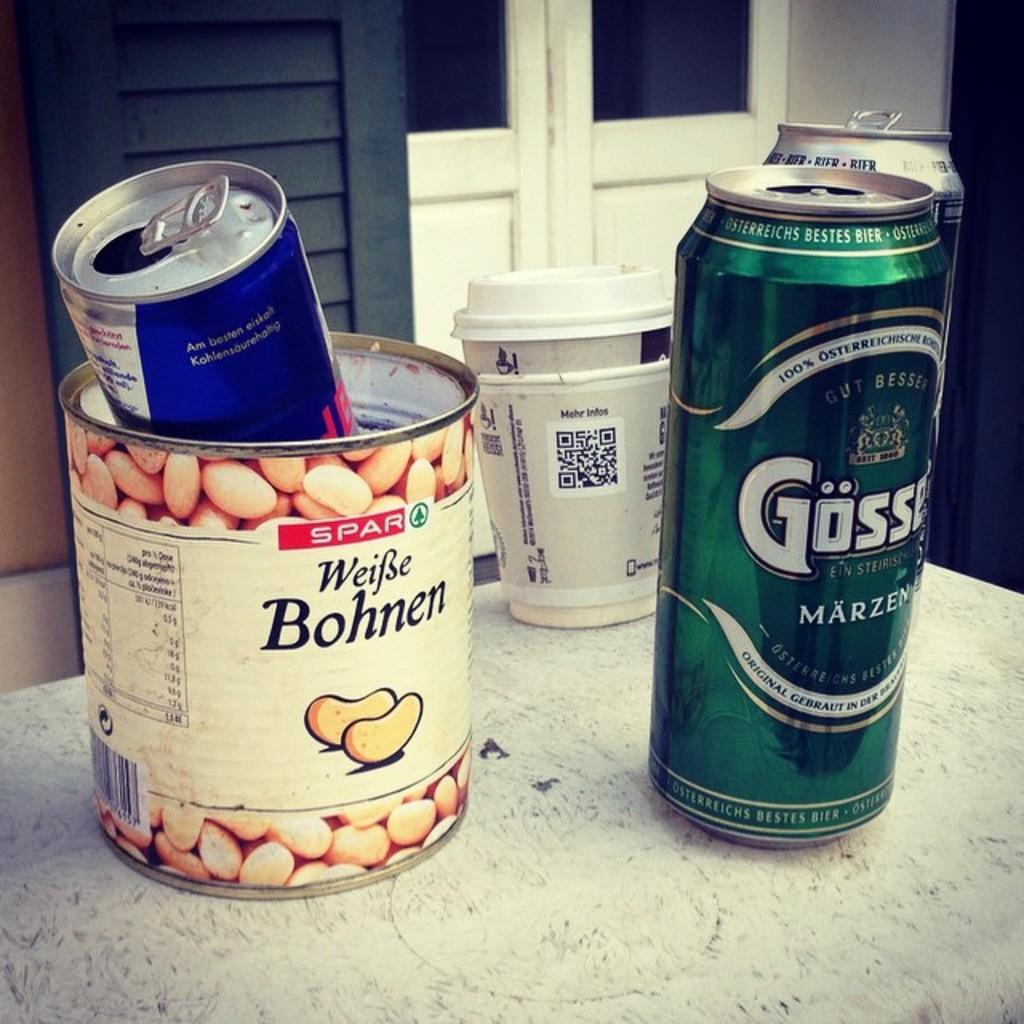<image>
Summarize the visual content of the image. On a white speckled counter are a can of Weifse Bohnen, and Osterreichs Bestes Bier 